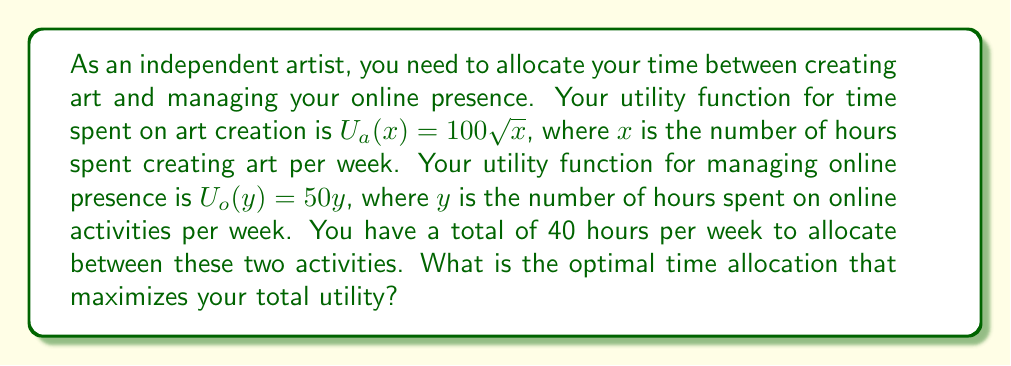Teach me how to tackle this problem. To solve this problem, we'll use utility theory and optimization techniques:

1) Let's define our objective function as the total utility:
   $U_{total} = U_a(x) + U_o(y) = 100\sqrt{x} + 50y$

2) We have a constraint: $x + y = 40$ (total available time)

3) We can substitute $y = 40 - x$ into our utility function:
   $U_{total} = 100\sqrt{x} + 50(40-x) = 100\sqrt{x} + 2000 - 50x$

4) To find the maximum utility, we differentiate $U_{total}$ with respect to $x$ and set it to zero:

   $$\frac{dU_{total}}{dx} = \frac{50}{\sqrt{x}} - 50 = 0$$

5) Solving this equation:
   $\frac{50}{\sqrt{x}} = 50$
   $\sqrt{x} = 1$
   $x = 1$

6) This critical point gives us a maximum (we can verify by checking the second derivative).

7) Therefore, the optimal time spent on creating art is 1 hour per week.

8) The remaining time (39 hours) should be spent on managing online presence.

9) We can verify the total utility:
   $U_{total} = 100\sqrt{1} + 50(39) = 100 + 1950 = 2050$
Answer: The optimal time allocation is 1 hour per week for creating art and 39 hours per week for managing online presence, resulting in a maximum total utility of 2050. 